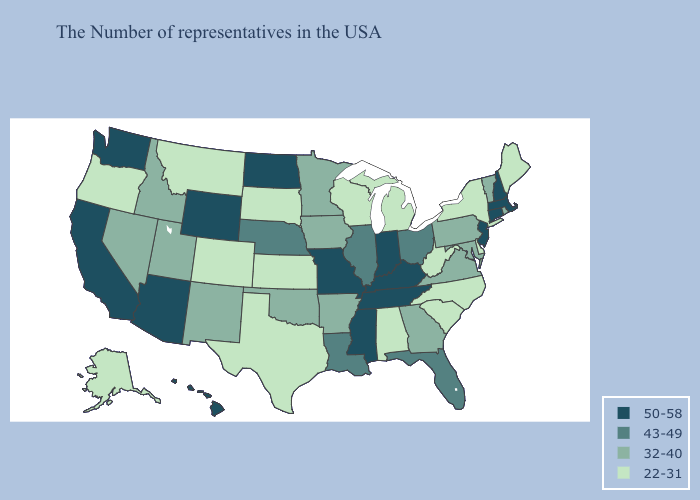Does Tennessee have a higher value than Arkansas?
Give a very brief answer. Yes. What is the highest value in states that border Indiana?
Concise answer only. 50-58. Does Michigan have a higher value than Alabama?
Answer briefly. No. Which states have the lowest value in the USA?
Answer briefly. Maine, New York, Delaware, North Carolina, South Carolina, West Virginia, Michigan, Alabama, Wisconsin, Kansas, Texas, South Dakota, Colorado, Montana, Oregon, Alaska. Which states have the lowest value in the MidWest?
Short answer required. Michigan, Wisconsin, Kansas, South Dakota. What is the value of Nebraska?
Be succinct. 43-49. What is the lowest value in the USA?
Short answer required. 22-31. Which states have the lowest value in the West?
Short answer required. Colorado, Montana, Oregon, Alaska. Does Wisconsin have the lowest value in the MidWest?
Answer briefly. Yes. Does New Hampshire have the highest value in the Northeast?
Quick response, please. Yes. What is the value of North Dakota?
Quick response, please. 50-58. Does Vermont have the highest value in the Northeast?
Write a very short answer. No. Does New Hampshire have the highest value in the USA?
Concise answer only. Yes. Name the states that have a value in the range 22-31?
Give a very brief answer. Maine, New York, Delaware, North Carolina, South Carolina, West Virginia, Michigan, Alabama, Wisconsin, Kansas, Texas, South Dakota, Colorado, Montana, Oregon, Alaska. Which states have the highest value in the USA?
Write a very short answer. Massachusetts, New Hampshire, Connecticut, New Jersey, Kentucky, Indiana, Tennessee, Mississippi, Missouri, North Dakota, Wyoming, Arizona, California, Washington, Hawaii. 